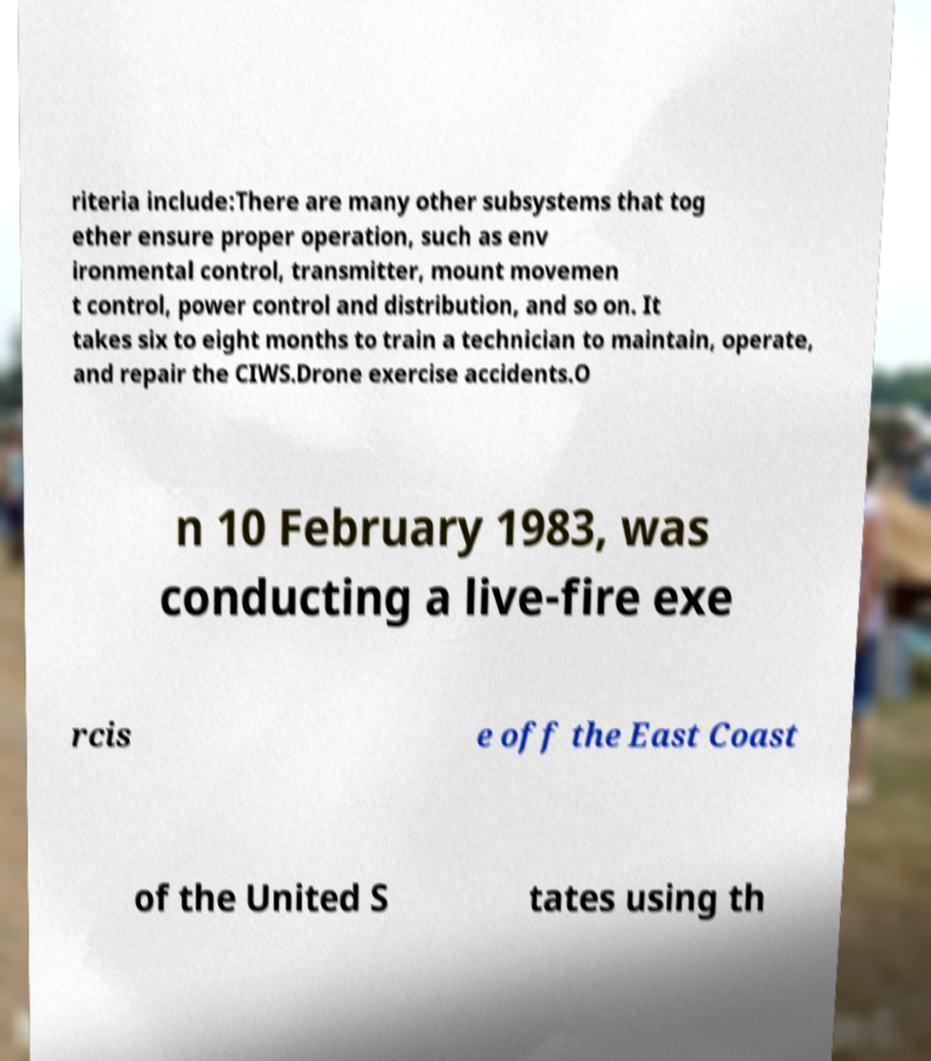Can you accurately transcribe the text from the provided image for me? riteria include:There are many other subsystems that tog ether ensure proper operation, such as env ironmental control, transmitter, mount movemen t control, power control and distribution, and so on. It takes six to eight months to train a technician to maintain, operate, and repair the CIWS.Drone exercise accidents.O n 10 February 1983, was conducting a live-fire exe rcis e off the East Coast of the United S tates using th 